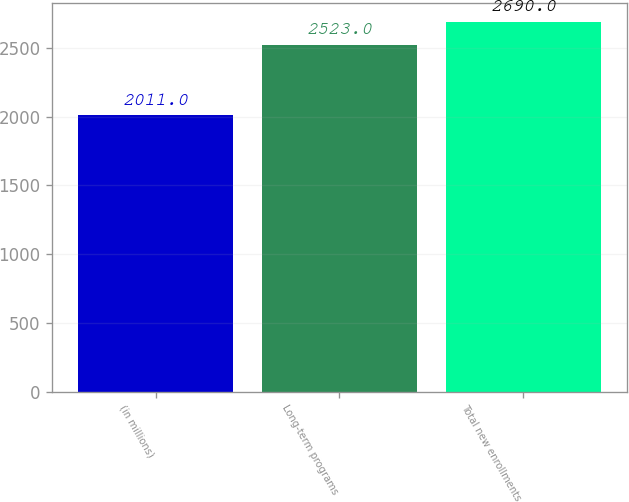Convert chart to OTSL. <chart><loc_0><loc_0><loc_500><loc_500><bar_chart><fcel>(in millions)<fcel>Long-term programs<fcel>Total new enrollments<nl><fcel>2011<fcel>2523<fcel>2690<nl></chart> 